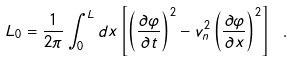<formula> <loc_0><loc_0><loc_500><loc_500>L _ { 0 } = \frac { 1 } { 2 \pi } \int _ { 0 } ^ { L } d x \left [ \left ( \frac { \partial \varphi } { \partial t } \right ) ^ { 2 } - { v _ { n } ^ { 2 } } \left ( \frac { \partial \varphi } { \partial x } \right ) ^ { 2 } \right ] \ .</formula> 